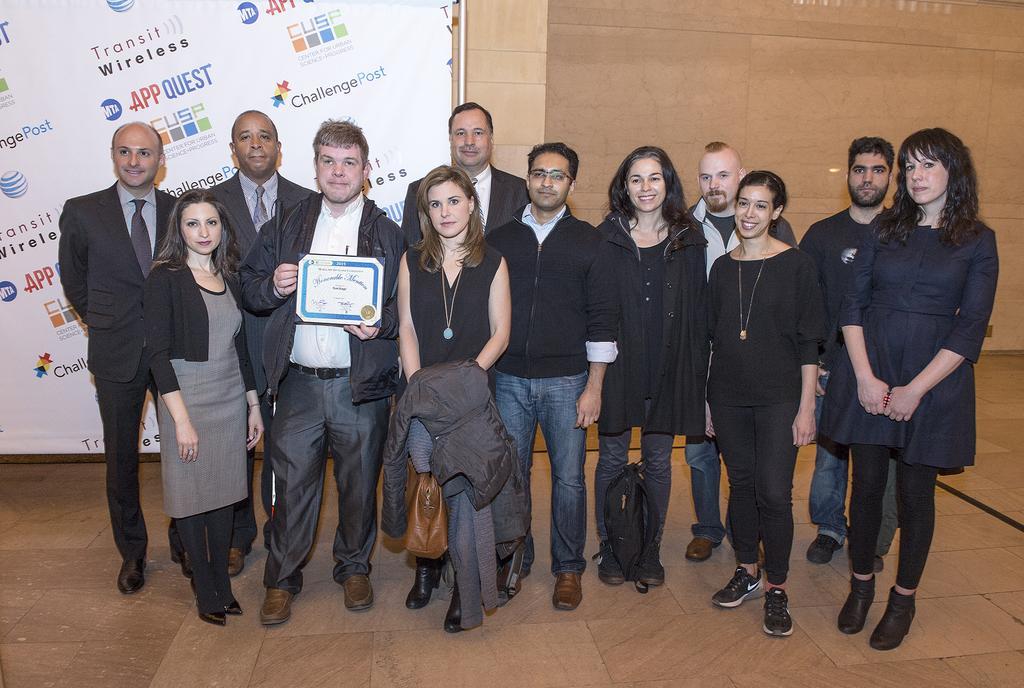Please provide a concise description of this image. In this picture there are people in the center of the image and there is a poster on the wall, on the left side of the image. 